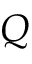<formula> <loc_0><loc_0><loc_500><loc_500>Q</formula> 